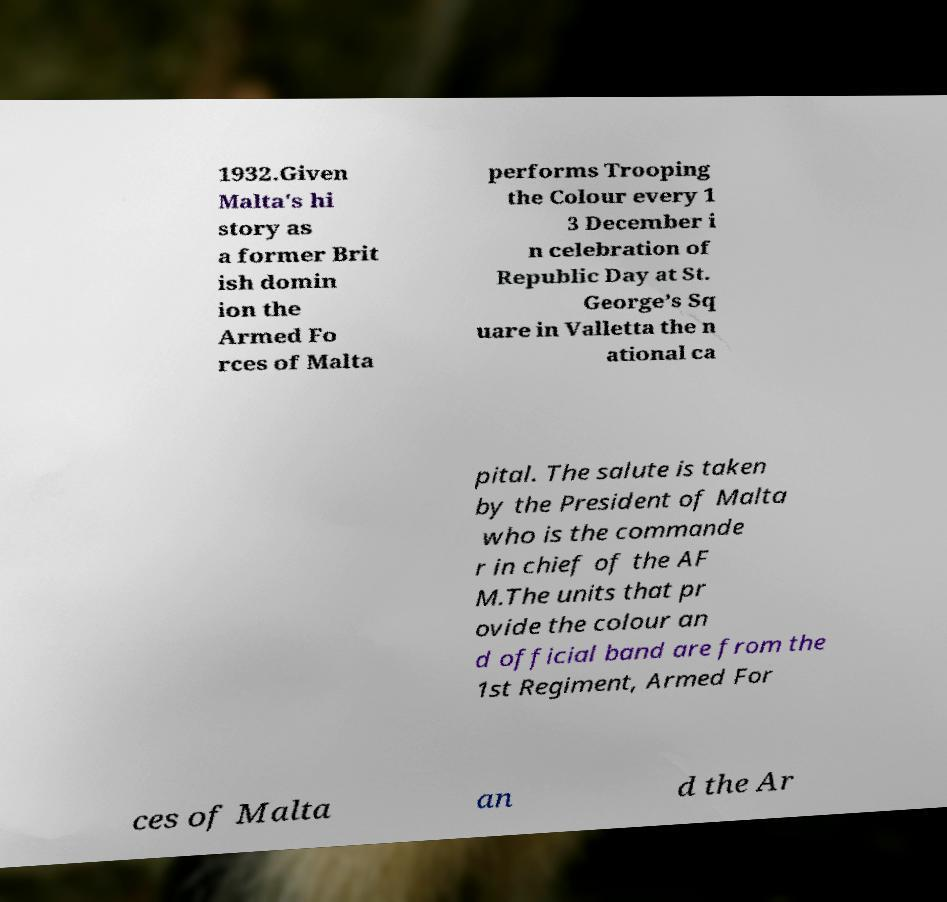There's text embedded in this image that I need extracted. Can you transcribe it verbatim? 1932.Given Malta's hi story as a former Brit ish domin ion the Armed Fo rces of Malta performs Trooping the Colour every 1 3 December i n celebration of Republic Day at St. George’s Sq uare in Valletta the n ational ca pital. The salute is taken by the President of Malta who is the commande r in chief of the AF M.The units that pr ovide the colour an d official band are from the 1st Regiment, Armed For ces of Malta an d the Ar 